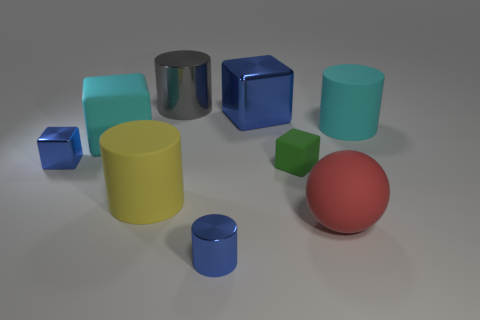Does the big metallic block have the same color as the tiny cylinder?
Give a very brief answer. Yes. There is another cube that is the same color as the large shiny cube; what is its size?
Provide a short and direct response. Small. There is a large rubber cylinder that is to the left of the green matte cube; what number of small blue shiny objects are to the left of it?
Your response must be concise. 1. There is a cyan matte thing on the right side of the small matte cube; is it the same shape as the object behind the large blue metallic cube?
Make the answer very short. Yes. What number of shiny blocks are in front of the cyan matte cylinder?
Provide a succinct answer. 1. Is the cyan thing that is to the left of the tiny matte cube made of the same material as the small blue cylinder?
Offer a terse response. No. What color is the other tiny thing that is the same shape as the gray thing?
Offer a very short reply. Blue. What is the shape of the large gray metallic object?
Provide a succinct answer. Cylinder. What number of objects are either tiny blocks or cyan rubber cylinders?
Provide a succinct answer. 3. Does the small metal object behind the sphere have the same color as the metal cylinder that is in front of the green rubber object?
Offer a very short reply. Yes. 